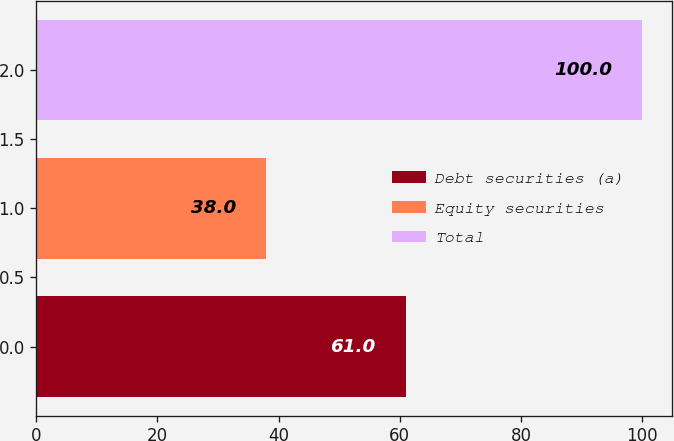Convert chart to OTSL. <chart><loc_0><loc_0><loc_500><loc_500><bar_chart><fcel>Debt securities (a)<fcel>Equity securities<fcel>Total<nl><fcel>61<fcel>38<fcel>100<nl></chart> 